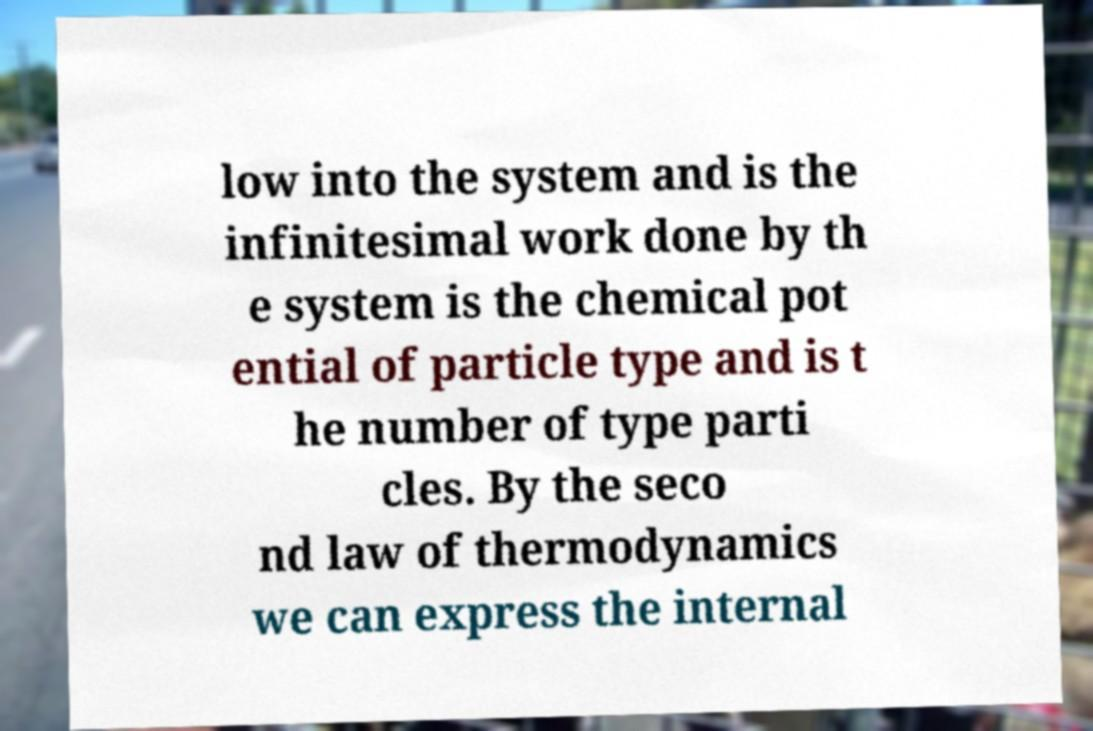What messages or text are displayed in this image? I need them in a readable, typed format. low into the system and is the infinitesimal work done by th e system is the chemical pot ential of particle type and is t he number of type parti cles. By the seco nd law of thermodynamics we can express the internal 